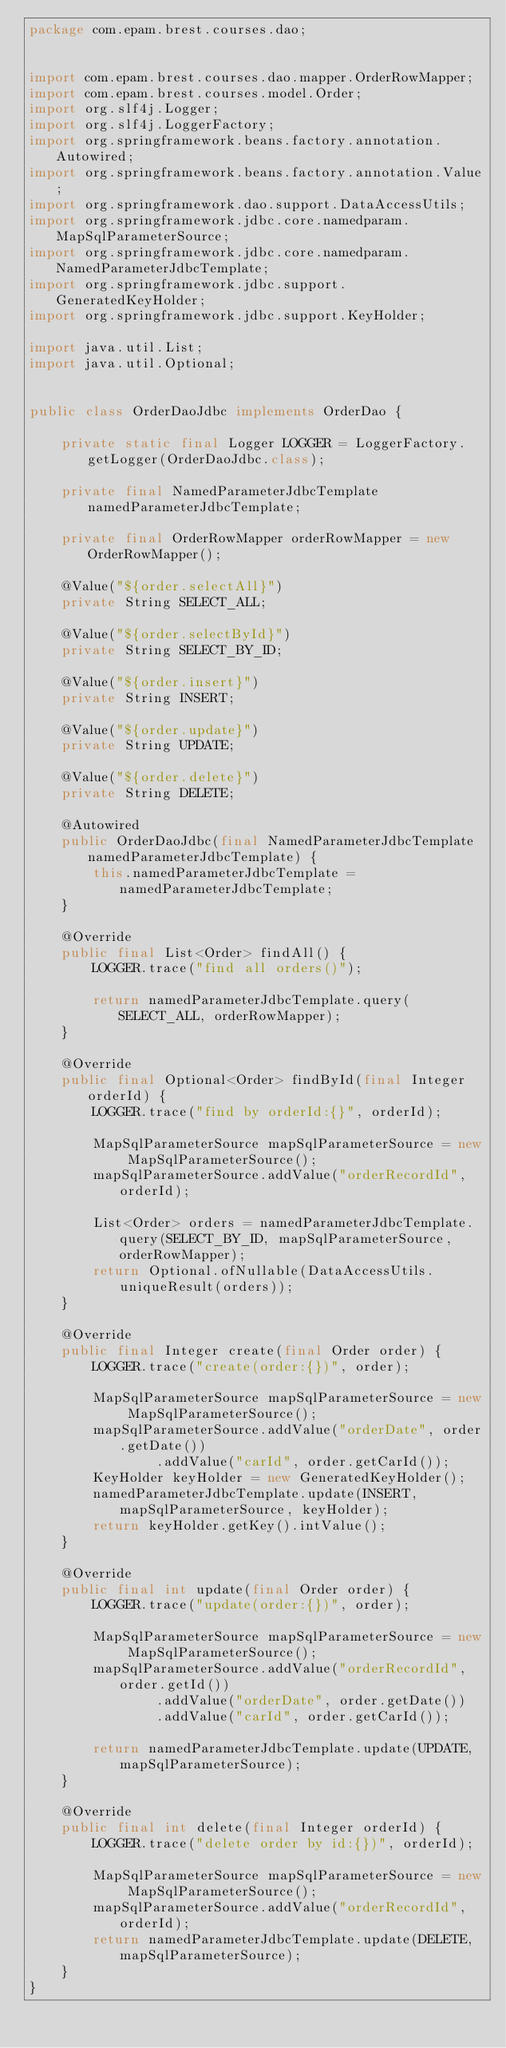<code> <loc_0><loc_0><loc_500><loc_500><_Java_>package com.epam.brest.courses.dao;


import com.epam.brest.courses.dao.mapper.OrderRowMapper;
import com.epam.brest.courses.model.Order;
import org.slf4j.Logger;
import org.slf4j.LoggerFactory;
import org.springframework.beans.factory.annotation.Autowired;
import org.springframework.beans.factory.annotation.Value;
import org.springframework.dao.support.DataAccessUtils;
import org.springframework.jdbc.core.namedparam.MapSqlParameterSource;
import org.springframework.jdbc.core.namedparam.NamedParameterJdbcTemplate;
import org.springframework.jdbc.support.GeneratedKeyHolder;
import org.springframework.jdbc.support.KeyHolder;

import java.util.List;
import java.util.Optional;


public class OrderDaoJdbc implements OrderDao {

    private static final Logger LOGGER = LoggerFactory.getLogger(OrderDaoJdbc.class);

    private final NamedParameterJdbcTemplate namedParameterJdbcTemplate;

    private final OrderRowMapper orderRowMapper = new OrderRowMapper();

    @Value("${order.selectAll}")
    private String SELECT_ALL;

    @Value("${order.selectById}")
    private String SELECT_BY_ID;

    @Value("${order.insert}")
    private String INSERT;

    @Value("${order.update}")
    private String UPDATE;

    @Value("${order.delete}")
    private String DELETE;

    @Autowired
    public OrderDaoJdbc(final NamedParameterJdbcTemplate namedParameterJdbcTemplate) {
        this.namedParameterJdbcTemplate = namedParameterJdbcTemplate;
    }

    @Override
    public final List<Order> findAll() {
        LOGGER.trace("find all orders()");

        return namedParameterJdbcTemplate.query(SELECT_ALL, orderRowMapper);
    }

    @Override
    public final Optional<Order> findById(final Integer orderId) {
        LOGGER.trace("find by orderId:{}", orderId);

        MapSqlParameterSource mapSqlParameterSource = new MapSqlParameterSource();
        mapSqlParameterSource.addValue("orderRecordId", orderId);

        List<Order> orders = namedParameterJdbcTemplate.query(SELECT_BY_ID, mapSqlParameterSource, orderRowMapper);
        return Optional.ofNullable(DataAccessUtils.uniqueResult(orders));
    }

    @Override
    public final Integer create(final Order order) {
        LOGGER.trace("create(order:{})", order);

        MapSqlParameterSource mapSqlParameterSource = new MapSqlParameterSource();
        mapSqlParameterSource.addValue("orderDate", order.getDate())
                .addValue("carId", order.getCarId());
        KeyHolder keyHolder = new GeneratedKeyHolder();
        namedParameterJdbcTemplate.update(INSERT, mapSqlParameterSource, keyHolder);
        return keyHolder.getKey().intValue();
    }

    @Override
    public final int update(final Order order) {
        LOGGER.trace("update(order:{})", order);

        MapSqlParameterSource mapSqlParameterSource = new MapSqlParameterSource();
        mapSqlParameterSource.addValue("orderRecordId", order.getId())
                .addValue("orderDate", order.getDate())
                .addValue("carId", order.getCarId());

        return namedParameterJdbcTemplate.update(UPDATE, mapSqlParameterSource);
    }

    @Override
    public final int delete(final Integer orderId) {
        LOGGER.trace("delete order by id:{})", orderId);

        MapSqlParameterSource mapSqlParameterSource = new MapSqlParameterSource();
        mapSqlParameterSource.addValue("orderRecordId", orderId);
        return namedParameterJdbcTemplate.update(DELETE, mapSqlParameterSource);
    }
}
</code> 